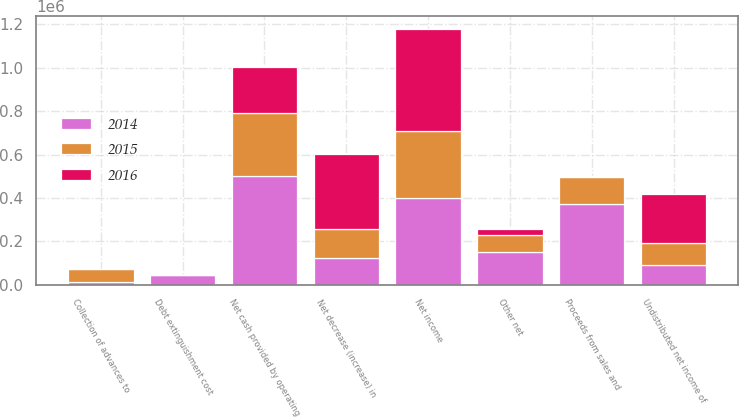<chart> <loc_0><loc_0><loc_500><loc_500><stacked_bar_chart><ecel><fcel>Net income<fcel>Undistributed net income of<fcel>Debt extinguishment cost<fcel>Other net<fcel>Net cash provided by operating<fcel>Net decrease (increase) in<fcel>Collection of advances to<fcel>Proceeds from sales and<nl><fcel>2016<fcel>469050<fcel>226641<fcel>353<fcel>31048<fcel>211714<fcel>347118<fcel>60<fcel>3878<nl><fcel>2015<fcel>309471<fcel>97781<fcel>135<fcel>78580<fcel>290405<fcel>132267<fcel>56000<fcel>124419<nl><fcel>2014<fcel>398462<fcel>93163<fcel>44422<fcel>149280<fcel>499001<fcel>124419<fcel>15000<fcel>372357<nl></chart> 